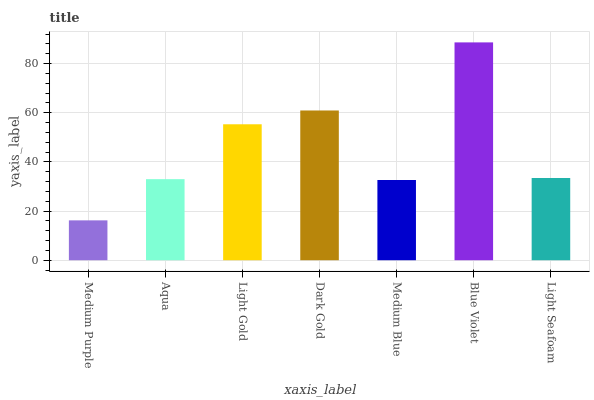Is Medium Purple the minimum?
Answer yes or no. Yes. Is Blue Violet the maximum?
Answer yes or no. Yes. Is Aqua the minimum?
Answer yes or no. No. Is Aqua the maximum?
Answer yes or no. No. Is Aqua greater than Medium Purple?
Answer yes or no. Yes. Is Medium Purple less than Aqua?
Answer yes or no. Yes. Is Medium Purple greater than Aqua?
Answer yes or no. No. Is Aqua less than Medium Purple?
Answer yes or no. No. Is Light Seafoam the high median?
Answer yes or no. Yes. Is Light Seafoam the low median?
Answer yes or no. Yes. Is Dark Gold the high median?
Answer yes or no. No. Is Light Gold the low median?
Answer yes or no. No. 